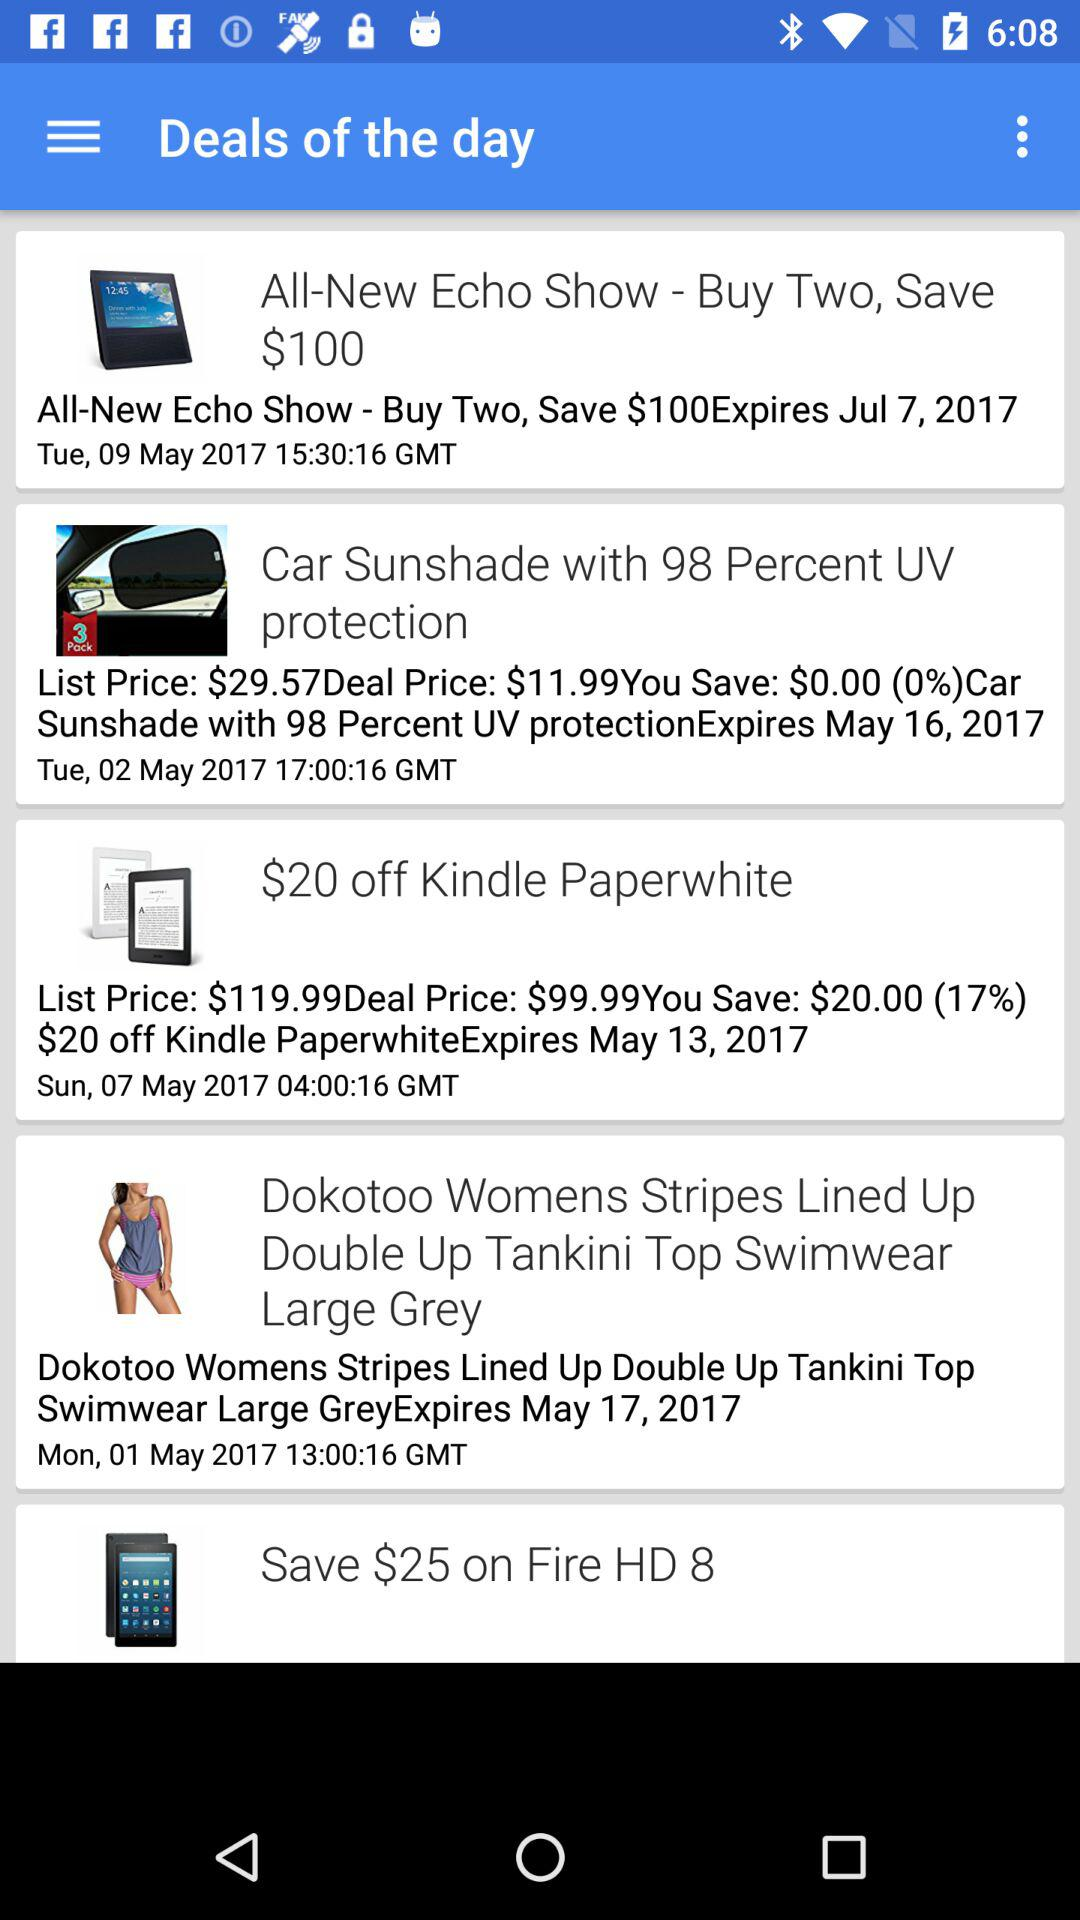How much is off on "Kindle Paperwhite" in $? On "Kindle Paperwhite", $20 is off. 